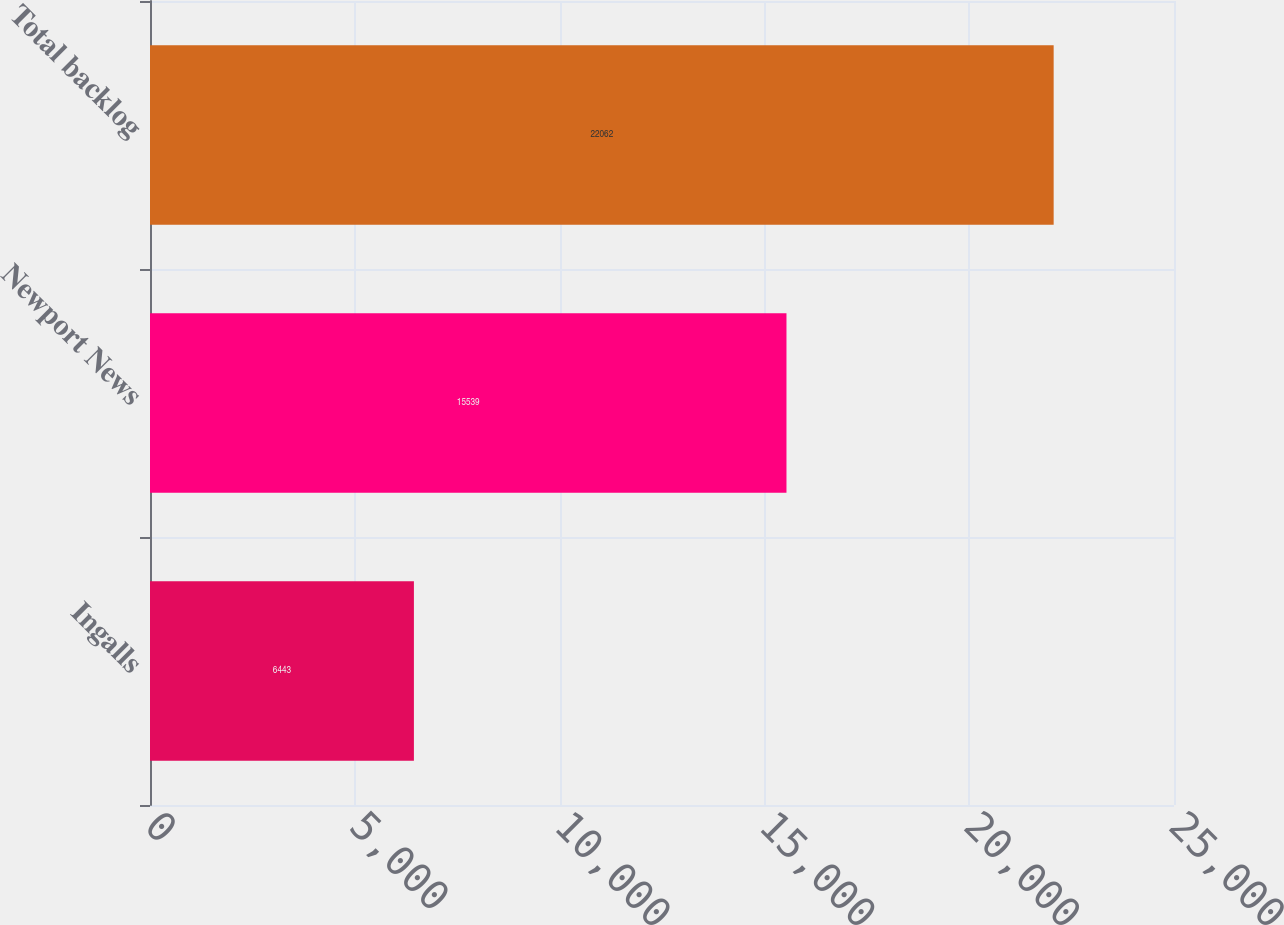<chart> <loc_0><loc_0><loc_500><loc_500><bar_chart><fcel>Ingalls<fcel>Newport News<fcel>Total backlog<nl><fcel>6443<fcel>15539<fcel>22062<nl></chart> 